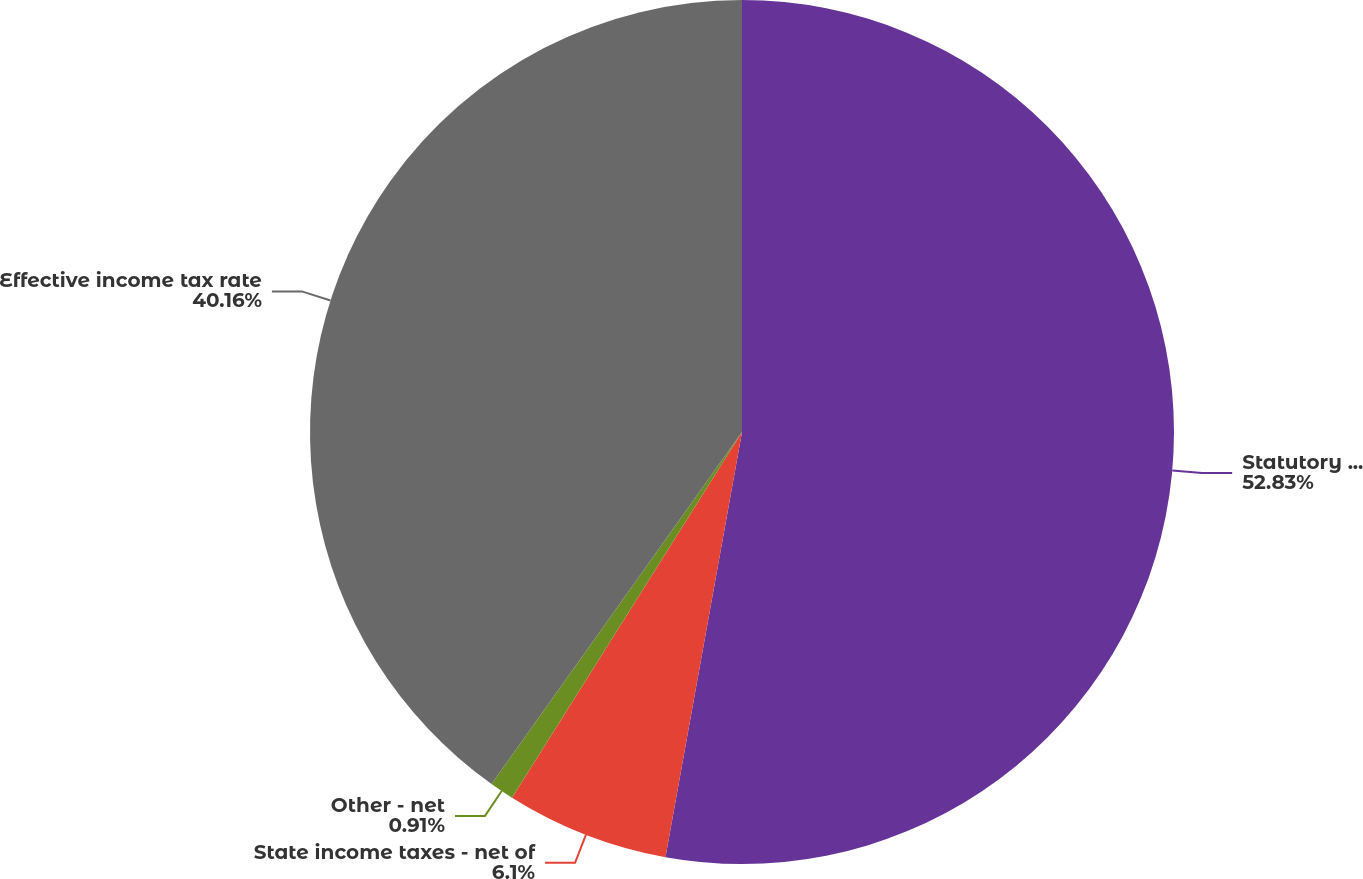Convert chart to OTSL. <chart><loc_0><loc_0><loc_500><loc_500><pie_chart><fcel>Statutory federal income tax<fcel>State income taxes - net of<fcel>Other - net<fcel>Effective income tax rate<nl><fcel>52.84%<fcel>6.1%<fcel>0.91%<fcel>40.16%<nl></chart> 